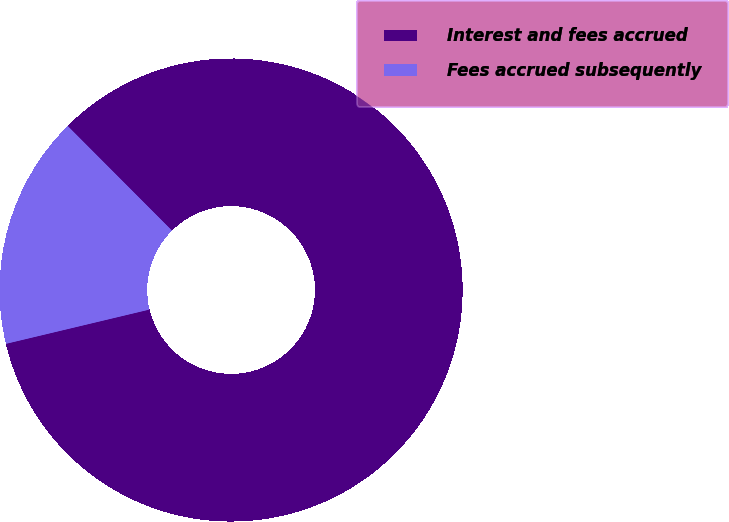Convert chart. <chart><loc_0><loc_0><loc_500><loc_500><pie_chart><fcel>Interest and fees accrued<fcel>Fees accrued subsequently<nl><fcel>83.74%<fcel>16.26%<nl></chart> 